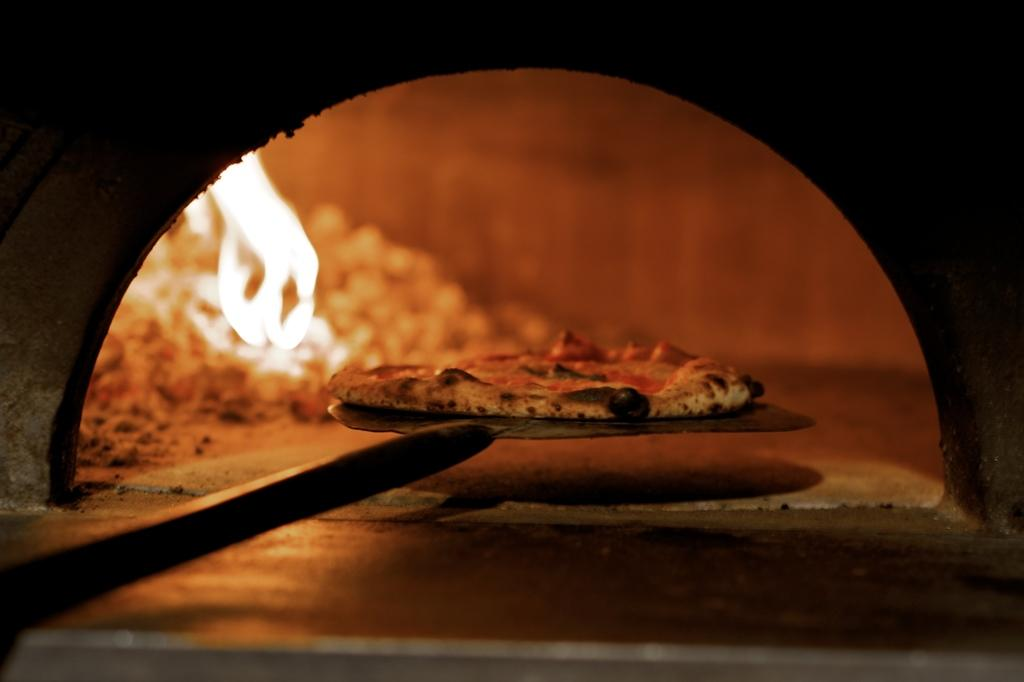What is the main subject of the image? There is a pie in the image. How is the pie being held or supported? The pie is on a large spatula. What can be seen on the opposite side of the pie? There is fire visible on the backside of the image. What type of silver sponge is being used to extinguish the fire in the image? There is no silver sponge present in the image, nor is there any indication of a fire being extinguished. 